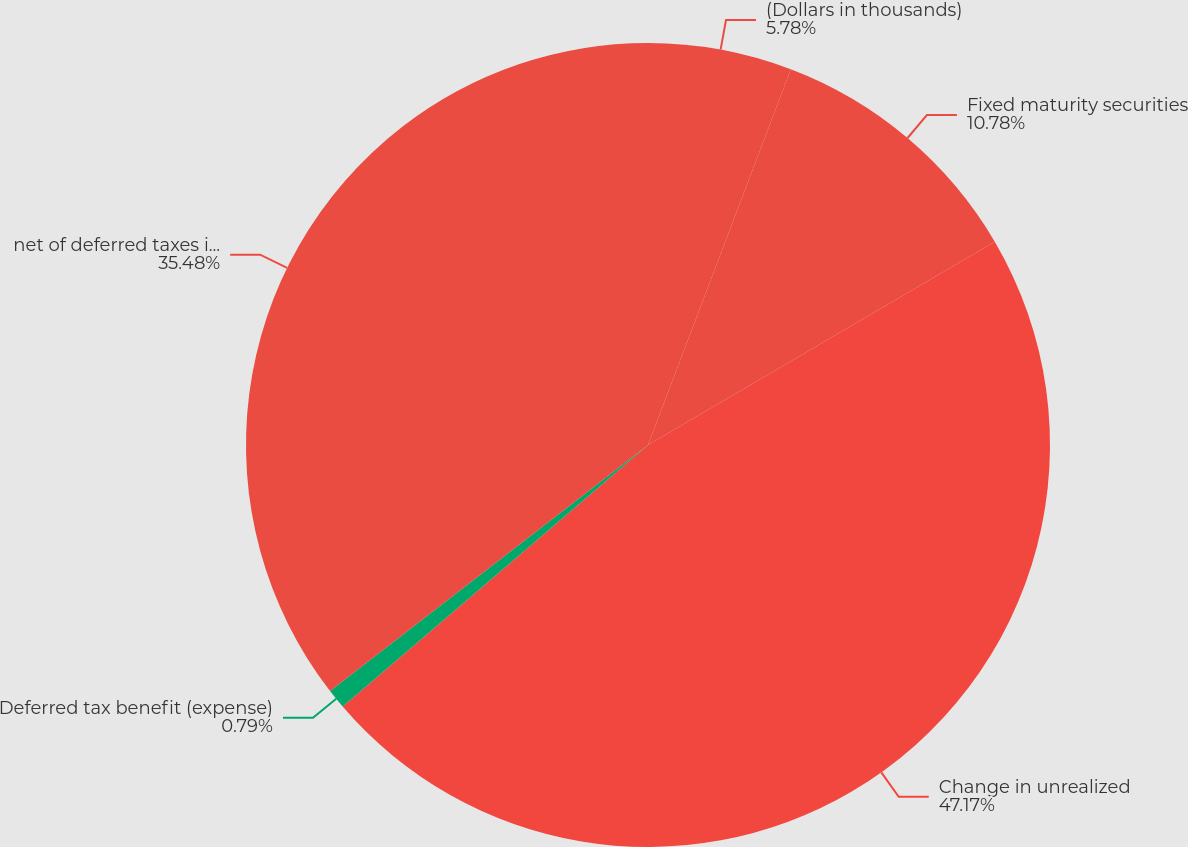Convert chart to OTSL. <chart><loc_0><loc_0><loc_500><loc_500><pie_chart><fcel>(Dollars in thousands)<fcel>Fixed maturity securities<fcel>Change in unrealized<fcel>Deferred tax benefit (expense)<fcel>net of deferred taxes included<nl><fcel>5.78%<fcel>10.78%<fcel>47.17%<fcel>0.79%<fcel>35.48%<nl></chart> 